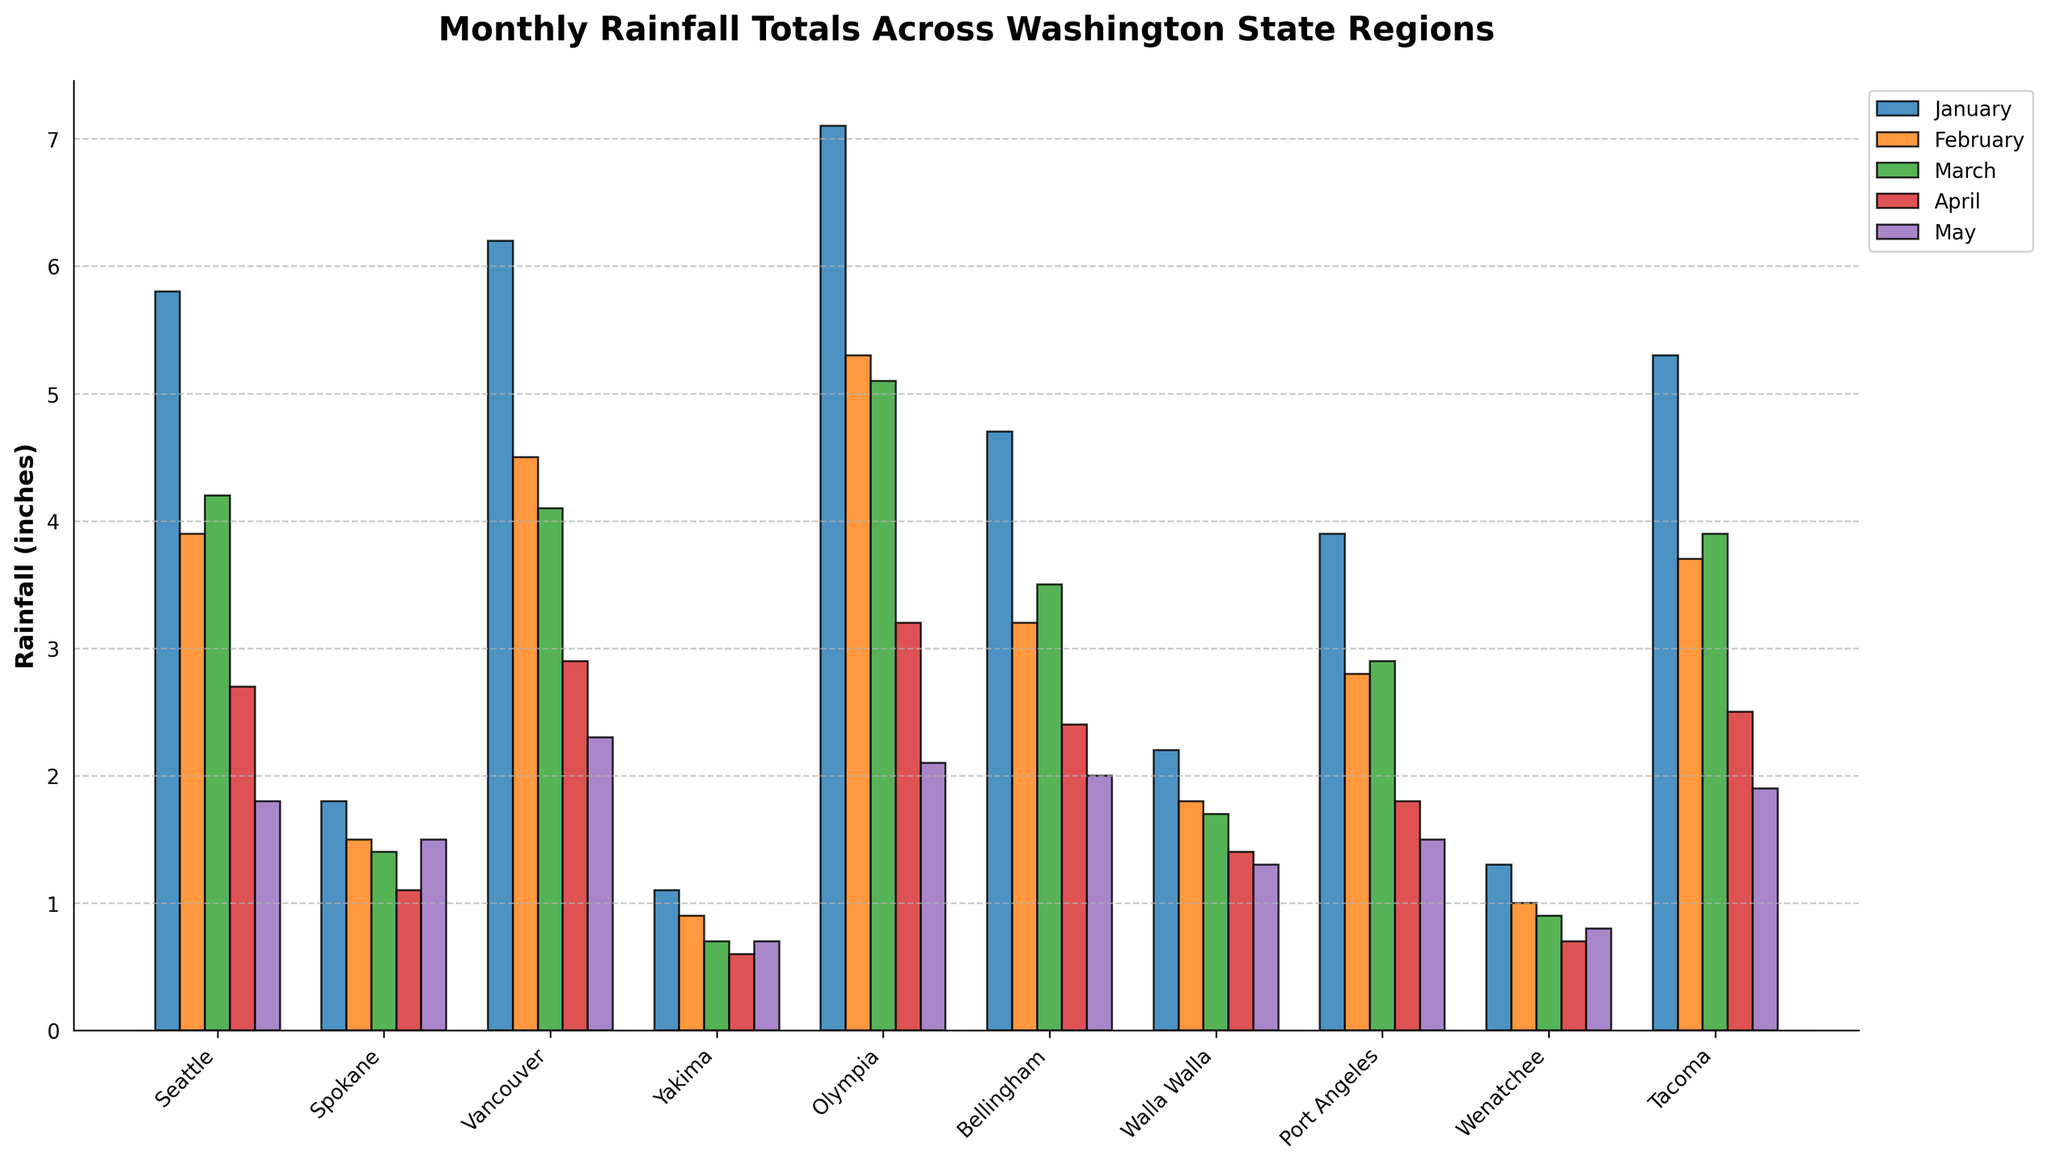What region has the highest rainfall in January? Find the tallest bar for January. Seattle has a bar that's 5.8 inches tall.
Answer: Seattle Which month has the highest rainfall in the state? Look for the highest bar across all months. Olympia in January has the highest bar, at 7.1 inches.
Answer: January How much more rainfall does Vancouver receive in January compared to April? Find Vancouver's bars for January and April, subtract April from January (6.2 - 2.9).
Answer: 3.3 inches Which region had the least amount of rainfall on average over the five months? Calculate the average rainfall for each region over the five months and compare. Yakima has the lowest total, averaging approximately 0.8 inches.
Answer: Yakima In which month does Tacoma receive less rainfall compared to Spokane? Compare the bars for Tacoma and Spokane month by month. Tacoma receives less rainfall than Spokane in May (1.9 < 1.5).
Answer: May How does the rainfall in Bellingham in February compare to Walla Walla in March? Look at the height of the bars for Bellingham in February and Walla Walla in March. Bellingham is 3.2 inches and Walla Walla is 1.7 inches. Bellingham has more.
Answer: Bellingham has more What is the total rainfall in Olympia over the five months? Sum the rainfall values for Olympia from January to May (7.1 + 5.3 + 5.1 + 3.2 + 2.1).
Answer: 22.8 inches Which region experienced the greatest decrease in rainfall from January to May? For each region, calculate the difference in rainfall from January to May and compare. Olympia had the greatest decrease from 7.1 to 2.1, a difference of 5 inches.
Answer: Olympia Comparing February, which two regions have nearly the same amount of rainfall? Look for February bars that are visually similar in height. Walla Walla and Wenatchee both have about 1.0 inches in February.
Answer: Walla Walla and Wenatchee In which month(s) does Seattle have more rainfall than Vancouver? Compare Seattle and Vancouver's bars month by month. Seattle has more rainfall than Vancouver in March (4.2 > 4.1) and in May (1.8 > 2.3).
Answer: March and May 